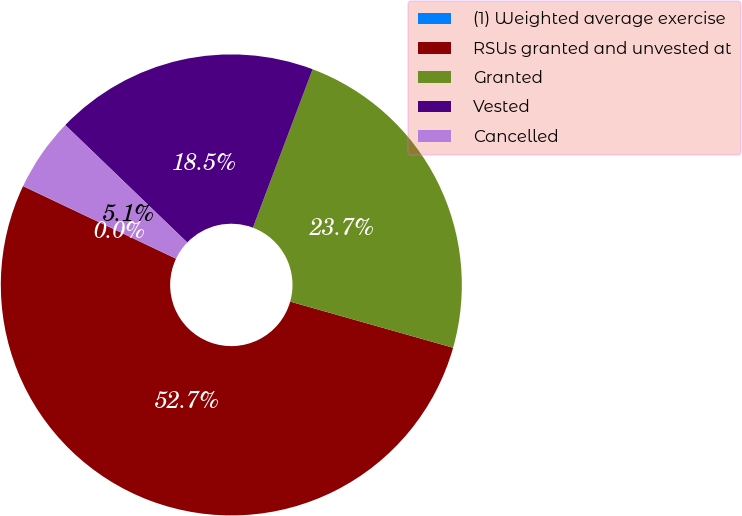<chart> <loc_0><loc_0><loc_500><loc_500><pie_chart><fcel>(1) Weighted average exercise<fcel>RSUs granted and unvested at<fcel>Granted<fcel>Vested<fcel>Cancelled<nl><fcel>0.02%<fcel>52.65%<fcel>23.65%<fcel>18.54%<fcel>5.13%<nl></chart> 